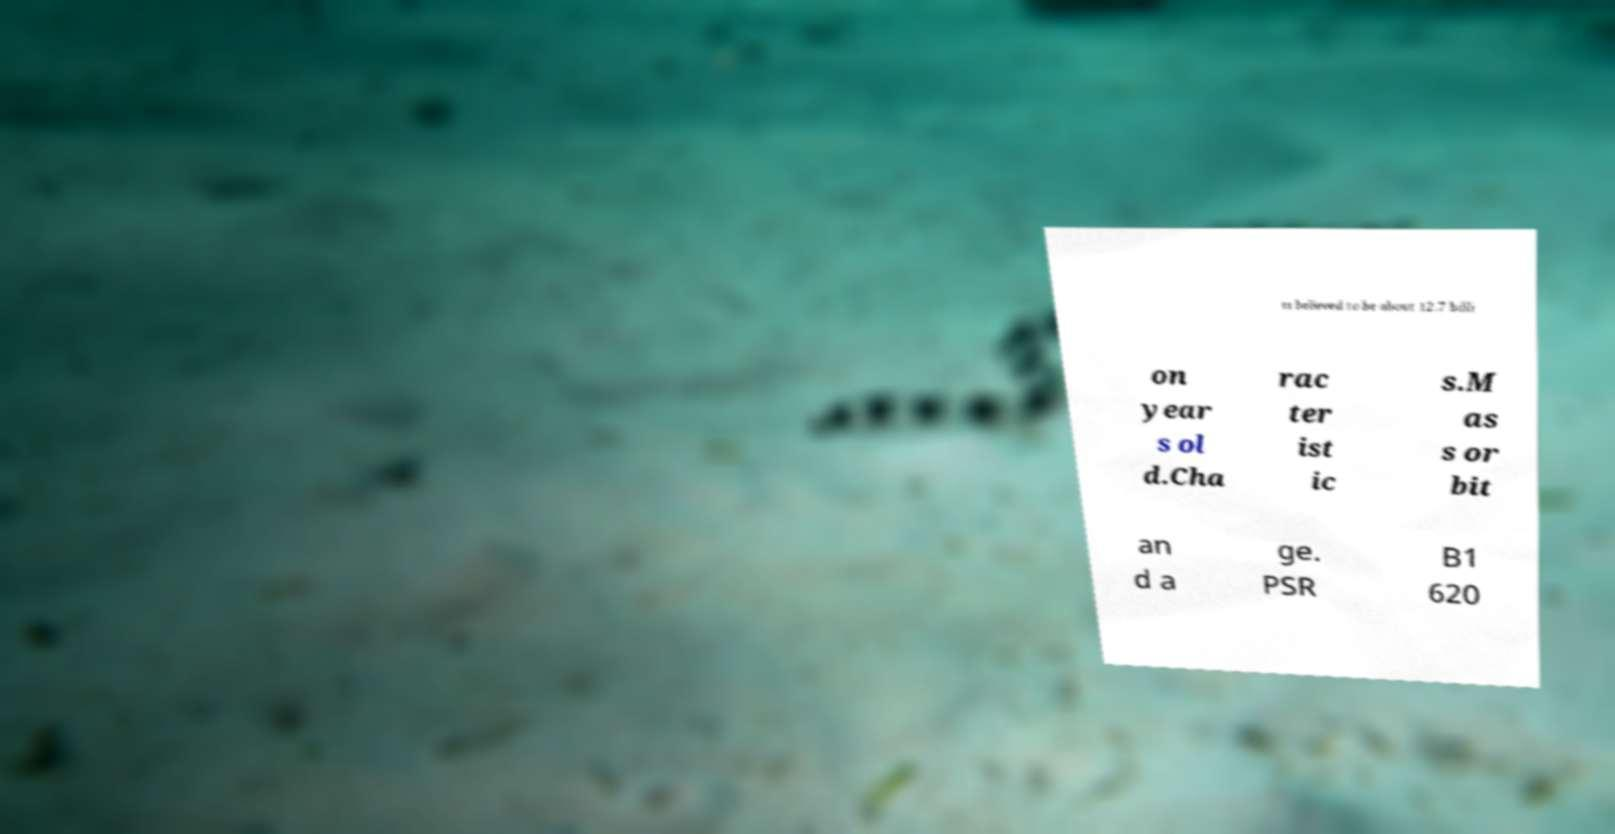Can you accurately transcribe the text from the provided image for me? ts believed to be about 12.7 billi on year s ol d.Cha rac ter ist ic s.M as s or bit an d a ge. PSR B1 620 